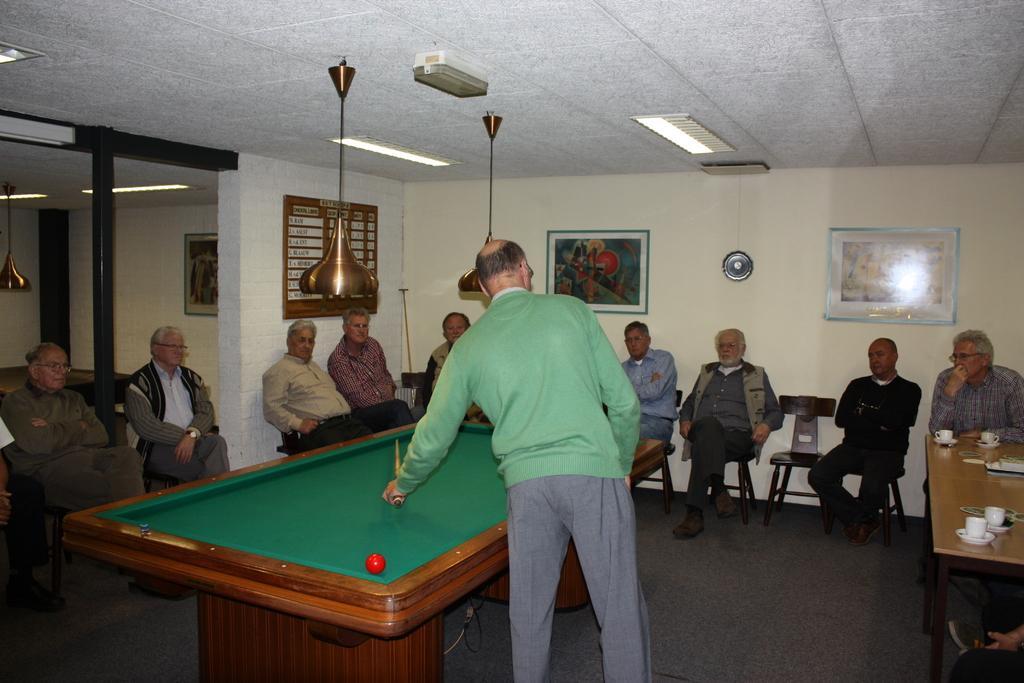Please provide a concise description of this image. In this image i can see few people sitting on chairs and a person standing holding a stick in front of a table and i can see a ball over here. In the background i can see a wall and a photo frame attached to it, on the top of the image i can see ceiling and lights. 